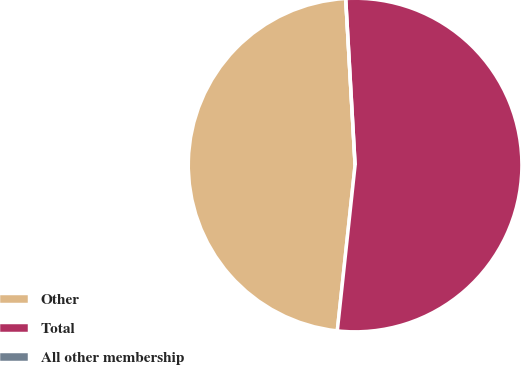Convert chart. <chart><loc_0><loc_0><loc_500><loc_500><pie_chart><fcel>Other<fcel>Total<fcel>All other membership<nl><fcel>47.4%<fcel>52.6%<fcel>0.0%<nl></chart> 